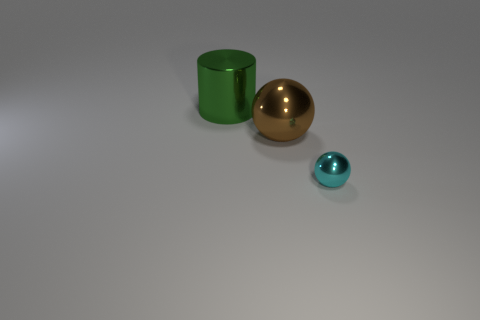Add 2 small shiny blocks. How many objects exist? 5 Subtract 1 balls. How many balls are left? 1 Subtract all brown spheres. How many spheres are left? 1 Subtract all big green shiny cylinders. Subtract all large green cylinders. How many objects are left? 1 Add 3 small cyan metallic balls. How many small cyan metallic balls are left? 4 Add 3 large things. How many large things exist? 5 Subtract 0 green blocks. How many objects are left? 3 Subtract all balls. How many objects are left? 1 Subtract all red balls. Subtract all yellow blocks. How many balls are left? 2 Subtract all yellow cylinders. How many red balls are left? 0 